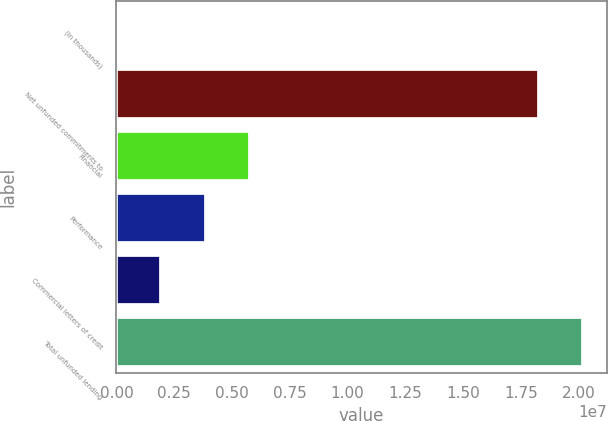Convert chart to OTSL. <chart><loc_0><loc_0><loc_500><loc_500><bar_chart><fcel>(In thousands)<fcel>Net unfunded commitments to<fcel>Financial<fcel>Performance<fcel>Commercial letters of credit<fcel>Total unfunded lending<nl><fcel>2016<fcel>1.82737e+07<fcel>5.79164e+06<fcel>3.86176e+06<fcel>1.93189e+06<fcel>2.02036e+07<nl></chart> 